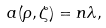<formula> <loc_0><loc_0><loc_500><loc_500>a ( \rho , \zeta ) = n \lambda ,</formula> 